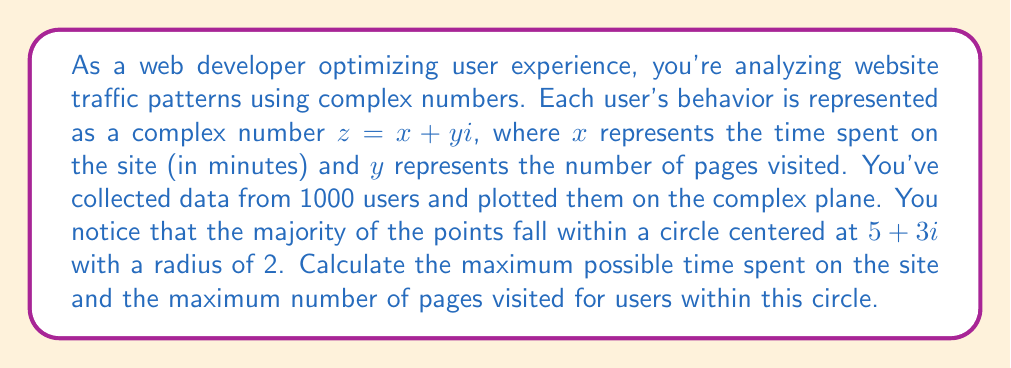Can you solve this math problem? To solve this problem, we need to understand the properties of complex numbers and circles in the complex plane.

1) The circle is centered at $5 + 3i$ with a radius of 2.

2) Any point $z = x + yi$ on the circle satisfies the equation:
   $|z - (5 + 3i)| = 2$

3) To find the maximum values, we need to consider the points at the extremities of the circle:

   - Maximum x (time spent) will be at the rightmost point of the circle
   - Maximum y (pages visited) will be at the topmost point of the circle

4) For the rightmost point:
   $z = (5 + 2) + 3i = 7 + 3i$
   
   The real part (7) represents the maximum time spent.

5) For the topmost point:
   $z = 5 + (3 + 2)i = 5 + 5i$
   
   The imaginary part (5) represents the maximum number of pages visited.

Therefore, the maximum time spent is 7 minutes, and the maximum number of pages visited is 5.
Answer: Maximum time spent: 7 minutes
Maximum pages visited: 5 pages 